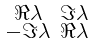<formula> <loc_0><loc_0><loc_500><loc_500>\begin{smallmatrix} \Re \lambda & \Im \lambda \\ - \Im \lambda & \Re \lambda \end{smallmatrix}</formula> 